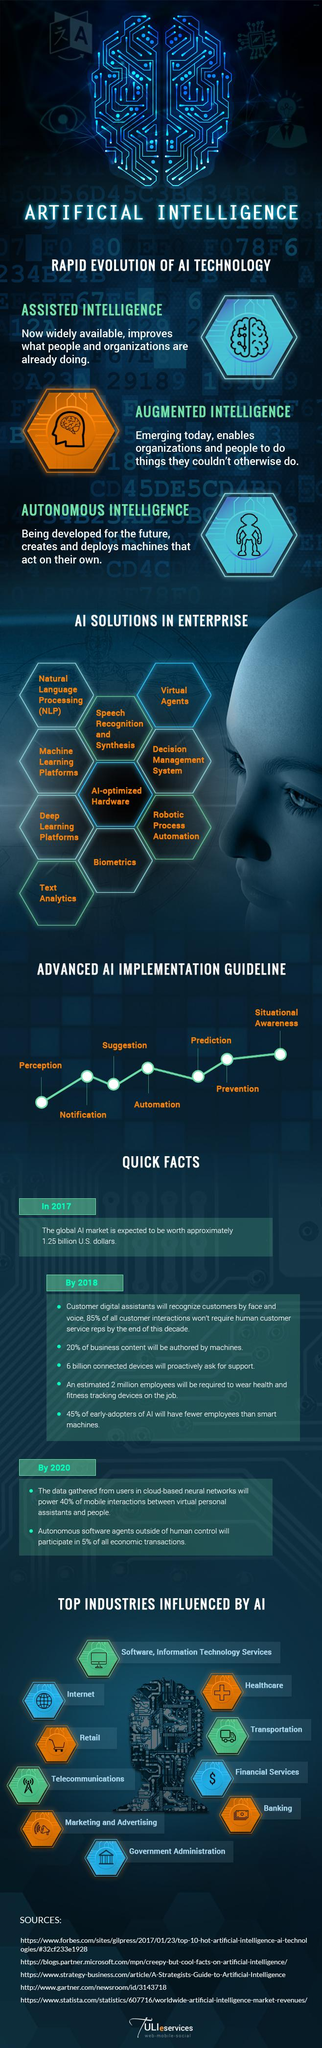Mention a couple of crucial points in this snapshot. AI has influenced a significant number of industries, with at least ten industries being impacted by AI. Artificial Intelligence technology can be classified into three main categories: Assisted Intelligence, Augmented Intelligence, and Autonomous Intelligence. Assisted Intelligence involves the use of AI algorithms and systems to enhance human capabilities, Augmented Intelligence adds a layer of AI to existing systems, and Autonomous Intelligence allows machines to operate independently without human intervention. The industry that is identified by the "$" symbol is financial services. The currency note is identified as belonging to the banking industry. A total of 10 AI solutions have been identified. 